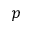Convert formula to latex. <formula><loc_0><loc_0><loc_500><loc_500>p</formula> 